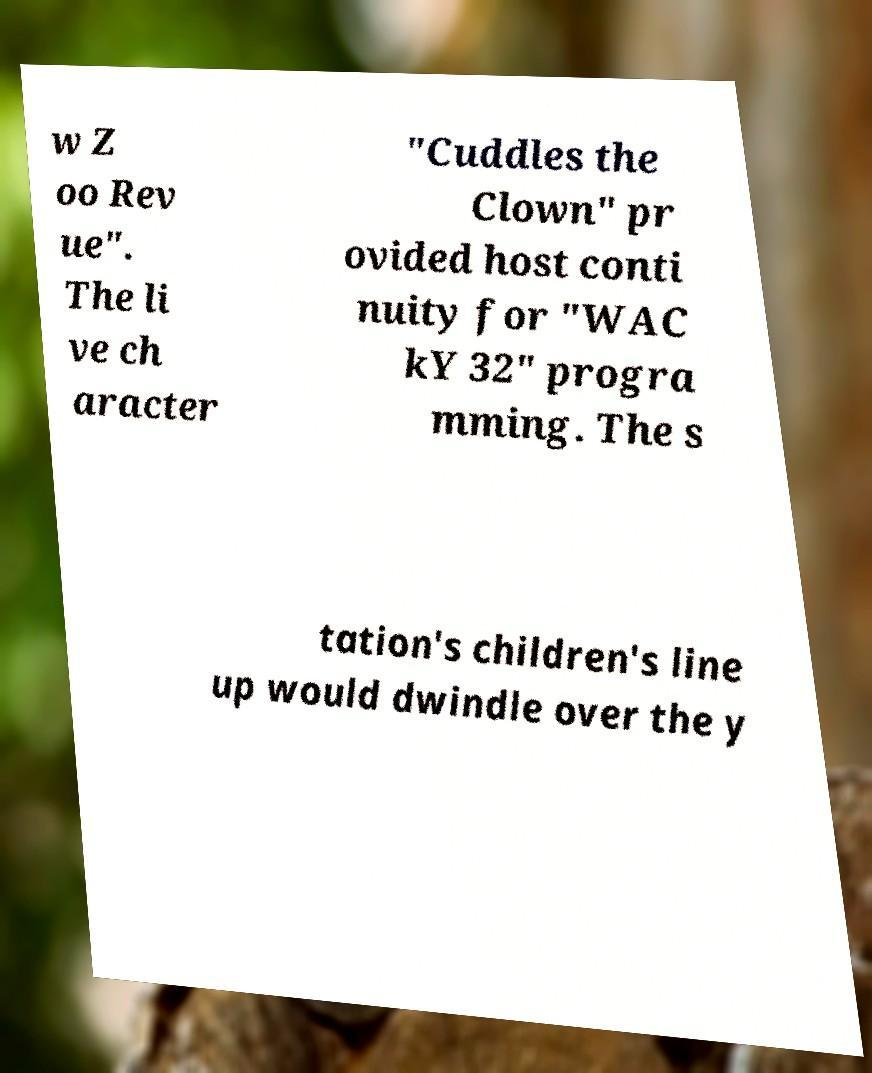Can you read and provide the text displayed in the image?This photo seems to have some interesting text. Can you extract and type it out for me? w Z oo Rev ue". The li ve ch aracter "Cuddles the Clown" pr ovided host conti nuity for "WAC kY 32" progra mming. The s tation's children's line up would dwindle over the y 